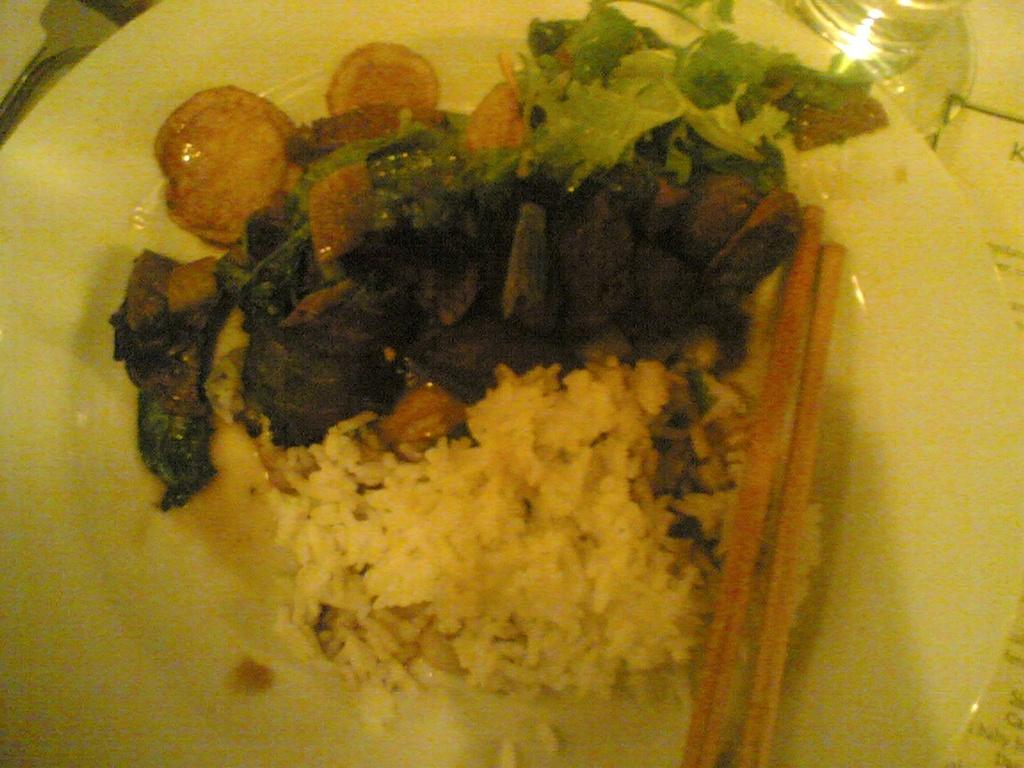What type of furniture is present in the image? There is a table in the image. What utensil can be seen in the image? There is a spoon in the image. What other utensil is present in the image? There are chopsticks in the image. What type of container is visible in the image? There is a glass in the image. What is on the plate in the image? There is a plate containing food in the image. What type of error is being corrected by the government in the image? There is no reference to an error or the government in the image. How many beads are present on the plate in the image? There are no beads present on the plate in the image; it contains food. 